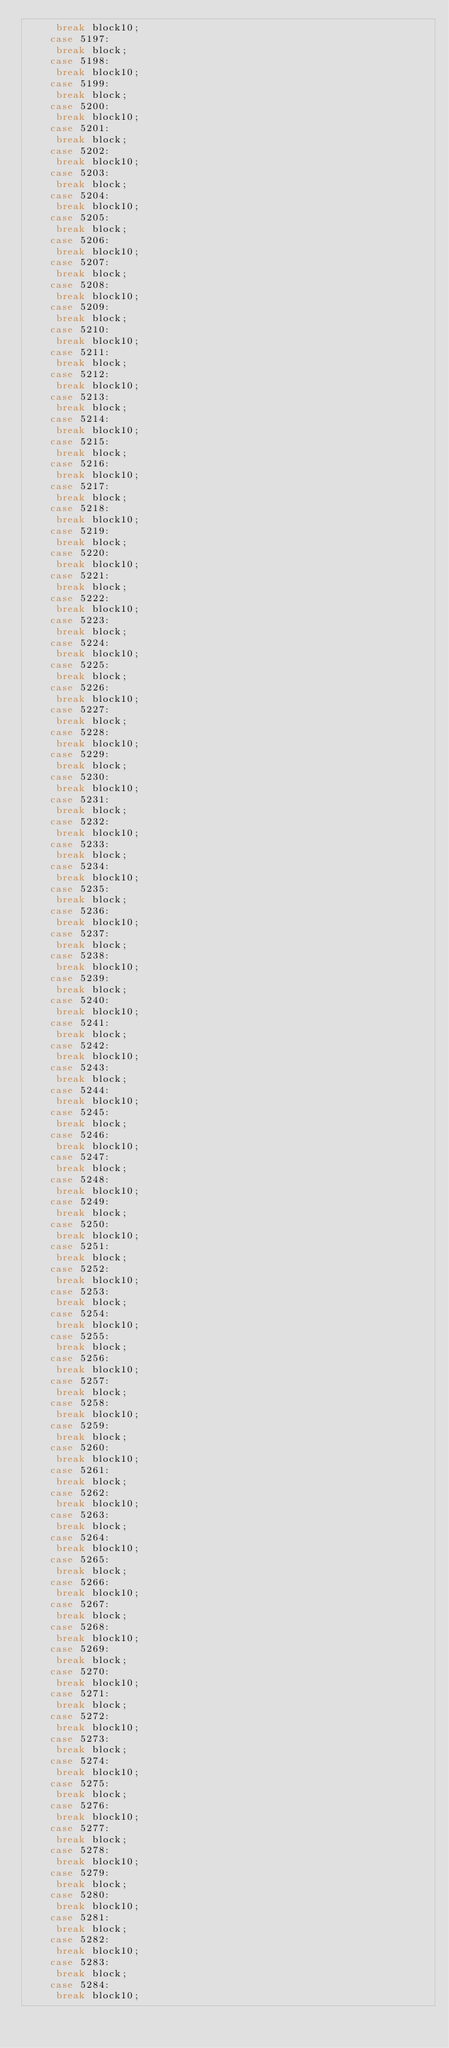<code> <loc_0><loc_0><loc_500><loc_500><_JavaScript_>     break block10;
    case 5197:
     break block;
    case 5198:
     break block10;
    case 5199:
     break block;
    case 5200:
     break block10;
    case 5201:
     break block;
    case 5202:
     break block10;
    case 5203:
     break block;
    case 5204:
     break block10;
    case 5205:
     break block;
    case 5206:
     break block10;
    case 5207:
     break block;
    case 5208:
     break block10;
    case 5209:
     break block;
    case 5210:
     break block10;
    case 5211:
     break block;
    case 5212:
     break block10;
    case 5213:
     break block;
    case 5214:
     break block10;
    case 5215:
     break block;
    case 5216:
     break block10;
    case 5217:
     break block;
    case 5218:
     break block10;
    case 5219:
     break block;
    case 5220:
     break block10;
    case 5221:
     break block;
    case 5222:
     break block10;
    case 5223:
     break block;
    case 5224:
     break block10;
    case 5225:
     break block;
    case 5226:
     break block10;
    case 5227:
     break block;
    case 5228:
     break block10;
    case 5229:
     break block;
    case 5230:
     break block10;
    case 5231:
     break block;
    case 5232:
     break block10;
    case 5233:
     break block;
    case 5234:
     break block10;
    case 5235:
     break block;
    case 5236:
     break block10;
    case 5237:
     break block;
    case 5238:
     break block10;
    case 5239:
     break block;
    case 5240:
     break block10;
    case 5241:
     break block;
    case 5242:
     break block10;
    case 5243:
     break block;
    case 5244:
     break block10;
    case 5245:
     break block;
    case 5246:
     break block10;
    case 5247:
     break block;
    case 5248:
     break block10;
    case 5249:
     break block;
    case 5250:
     break block10;
    case 5251:
     break block;
    case 5252:
     break block10;
    case 5253:
     break block;
    case 5254:
     break block10;
    case 5255:
     break block;
    case 5256:
     break block10;
    case 5257:
     break block;
    case 5258:
     break block10;
    case 5259:
     break block;
    case 5260:
     break block10;
    case 5261:
     break block;
    case 5262:
     break block10;
    case 5263:
     break block;
    case 5264:
     break block10;
    case 5265:
     break block;
    case 5266:
     break block10;
    case 5267:
     break block;
    case 5268:
     break block10;
    case 5269:
     break block;
    case 5270:
     break block10;
    case 5271:
     break block;
    case 5272:
     break block10;
    case 5273:
     break block;
    case 5274:
     break block10;
    case 5275:
     break block;
    case 5276:
     break block10;
    case 5277:
     break block;
    case 5278:
     break block10;
    case 5279:
     break block;
    case 5280:
     break block10;
    case 5281:
     break block;
    case 5282:
     break block10;
    case 5283:
     break block;
    case 5284:
     break block10;</code> 